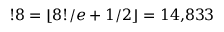<formula> <loc_0><loc_0><loc_500><loc_500>! 8 = \lfloor 8 ! / e + 1 / 2 \rfloor = 1 4 { , } 8 3 3</formula> 